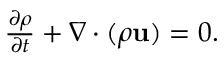<formula> <loc_0><loc_0><loc_500><loc_500>\begin{array} { r } { \frac { \partial \rho } { \partial t } + \nabla \cdot ( \rho u ) = 0 . } \end{array}</formula> 